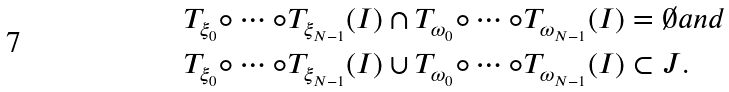Convert formula to latex. <formula><loc_0><loc_0><loc_500><loc_500>& T _ { \xi _ { 0 } } \circ \cdots \circ T _ { \xi _ { N - 1 } } ( I ) \cap T _ { \omega _ { 0 } } \circ \cdots \circ T _ { \omega _ { N - 1 } } ( I ) = \emptyset a n d \\ & T _ { \xi _ { 0 } } \circ \cdots \circ T _ { \xi _ { N - 1 } } ( I ) \cup T _ { \omega _ { 0 } } \circ \cdots \circ T _ { \omega _ { N - 1 } } ( I ) \subset J .</formula> 